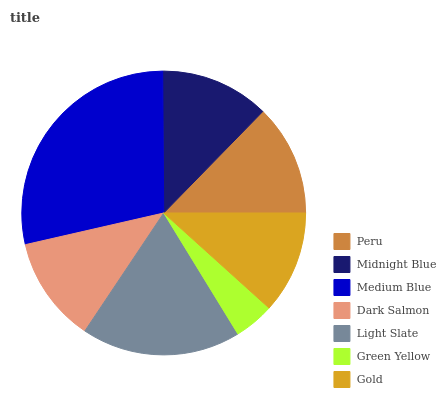Is Green Yellow the minimum?
Answer yes or no. Yes. Is Medium Blue the maximum?
Answer yes or no. Yes. Is Midnight Blue the minimum?
Answer yes or no. No. Is Midnight Blue the maximum?
Answer yes or no. No. Is Peru greater than Midnight Blue?
Answer yes or no. Yes. Is Midnight Blue less than Peru?
Answer yes or no. Yes. Is Midnight Blue greater than Peru?
Answer yes or no. No. Is Peru less than Midnight Blue?
Answer yes or no. No. Is Midnight Blue the high median?
Answer yes or no. Yes. Is Midnight Blue the low median?
Answer yes or no. Yes. Is Dark Salmon the high median?
Answer yes or no. No. Is Peru the low median?
Answer yes or no. No. 